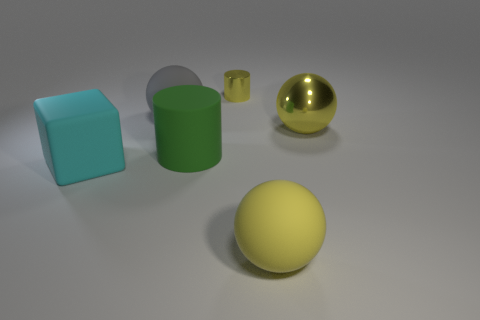Do the tiny metal cylinder and the large shiny object have the same color?
Make the answer very short. Yes. Are there an equal number of yellow metallic cylinders that are in front of the green thing and matte objects that are to the left of the yellow metallic cylinder?
Provide a short and direct response. No. What color is the large thing on the right side of the rubber ball in front of the large object that is to the left of the large gray object?
Your response must be concise. Yellow. Is there any other thing that is the same color as the metallic cylinder?
Ensure brevity in your answer.  Yes. There is a small shiny thing that is the same color as the large metal object; what shape is it?
Offer a very short reply. Cylinder. There is a cylinder that is behind the large gray sphere; what size is it?
Provide a succinct answer. Small. There is a gray rubber thing that is the same size as the yellow shiny ball; what shape is it?
Give a very brief answer. Sphere. Are the yellow object behind the large yellow metallic sphere and the large yellow sphere to the right of the big yellow rubber thing made of the same material?
Your response must be concise. Yes. What is the material of the yellow sphere behind the big matte thing to the left of the big gray rubber thing?
Offer a very short reply. Metal. There is a yellow metallic thing to the left of the big matte ball to the right of the sphere that is to the left of the tiny yellow object; what size is it?
Offer a very short reply. Small. 